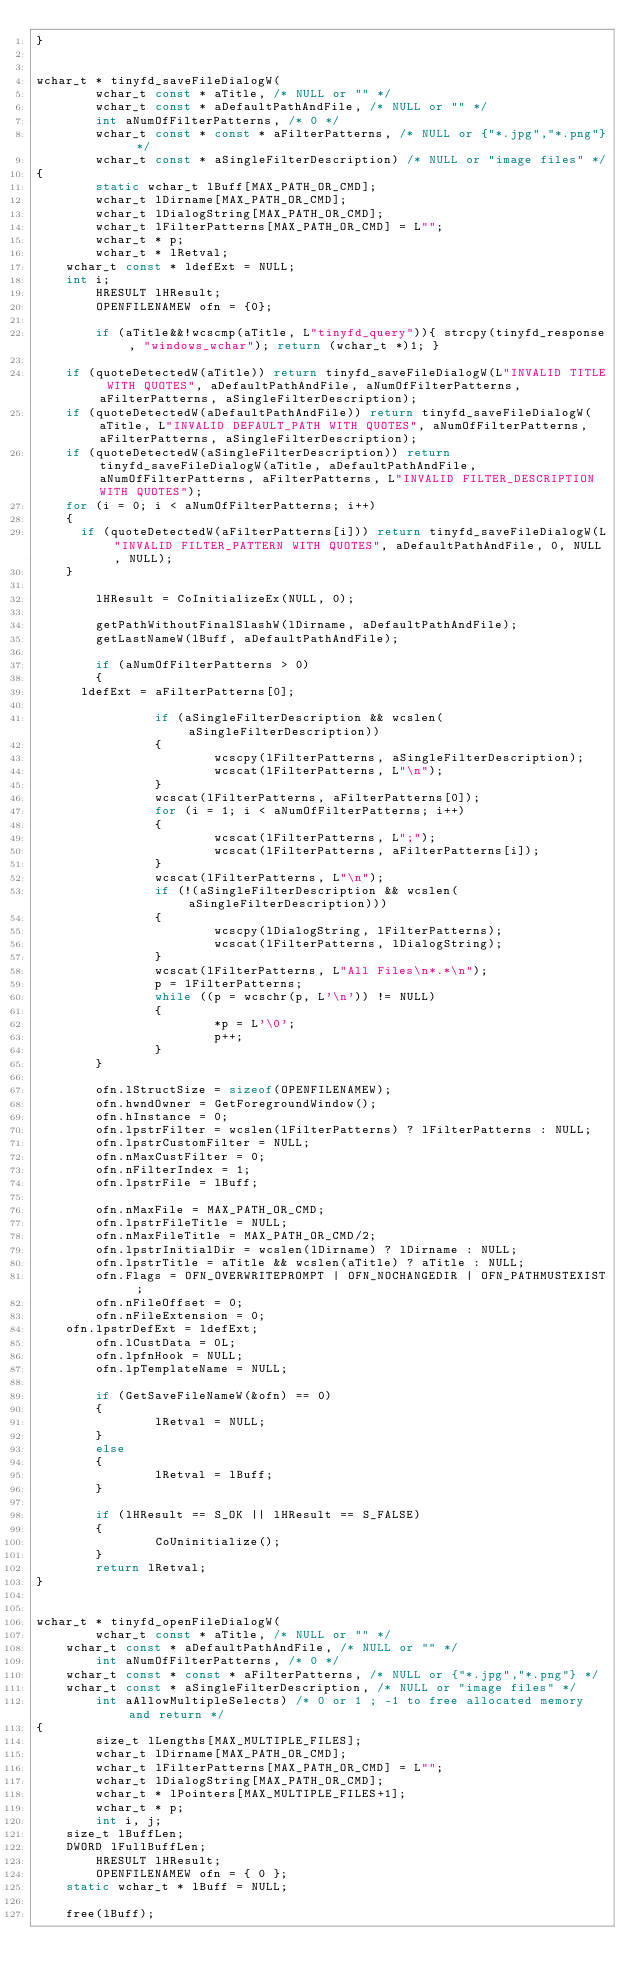<code> <loc_0><loc_0><loc_500><loc_500><_C_>}


wchar_t * tinyfd_saveFileDialogW(
        wchar_t const * aTitle, /* NULL or "" */
        wchar_t const * aDefaultPathAndFile, /* NULL or "" */
        int aNumOfFilterPatterns, /* 0 */
        wchar_t const * const * aFilterPatterns, /* NULL or {"*.jpg","*.png"} */
        wchar_t const * aSingleFilterDescription) /* NULL or "image files" */
{
        static wchar_t lBuff[MAX_PATH_OR_CMD];
        wchar_t lDirname[MAX_PATH_OR_CMD];
        wchar_t lDialogString[MAX_PATH_OR_CMD];
        wchar_t lFilterPatterns[MAX_PATH_OR_CMD] = L"";
        wchar_t * p;
        wchar_t * lRetval;
		wchar_t const * ldefExt = NULL;
		int i;
        HRESULT lHResult;
        OPENFILENAMEW ofn = {0};

        if (aTitle&&!wcscmp(aTitle, L"tinyfd_query")){ strcpy(tinyfd_response, "windows_wchar"); return (wchar_t *)1; }

		if (quoteDetectedW(aTitle)) return tinyfd_saveFileDialogW(L"INVALID TITLE WITH QUOTES", aDefaultPathAndFile, aNumOfFilterPatterns, aFilterPatterns, aSingleFilterDescription);
		if (quoteDetectedW(aDefaultPathAndFile)) return tinyfd_saveFileDialogW(aTitle, L"INVALID DEFAULT_PATH WITH QUOTES", aNumOfFilterPatterns, aFilterPatterns, aSingleFilterDescription);
		if (quoteDetectedW(aSingleFilterDescription)) return tinyfd_saveFileDialogW(aTitle, aDefaultPathAndFile, aNumOfFilterPatterns, aFilterPatterns, L"INVALID FILTER_DESCRIPTION WITH QUOTES");
		for (i = 0; i < aNumOfFilterPatterns; i++)
		{
			if (quoteDetectedW(aFilterPatterns[i])) return tinyfd_saveFileDialogW(L"INVALID FILTER_PATTERN WITH QUOTES", aDefaultPathAndFile, 0, NULL, NULL);
		}

        lHResult = CoInitializeEx(NULL, 0);

        getPathWithoutFinalSlashW(lDirname, aDefaultPathAndFile);
        getLastNameW(lBuff, aDefaultPathAndFile);

        if (aNumOfFilterPatterns > 0)
        {
			ldefExt = aFilterPatterns[0];

                if (aSingleFilterDescription && wcslen(aSingleFilterDescription))
                {
                        wcscpy(lFilterPatterns, aSingleFilterDescription);
                        wcscat(lFilterPatterns, L"\n");
                }
                wcscat(lFilterPatterns, aFilterPatterns[0]);
                for (i = 1; i < aNumOfFilterPatterns; i++)
                {
                        wcscat(lFilterPatterns, L";");
                        wcscat(lFilterPatterns, aFilterPatterns[i]);
                }
                wcscat(lFilterPatterns, L"\n");
                if (!(aSingleFilterDescription && wcslen(aSingleFilterDescription)))
                {
                        wcscpy(lDialogString, lFilterPatterns);
                        wcscat(lFilterPatterns, lDialogString);
                }
                wcscat(lFilterPatterns, L"All Files\n*.*\n");
                p = lFilterPatterns;
                while ((p = wcschr(p, L'\n')) != NULL)
                {
                        *p = L'\0';
                        p++;
                }
        }

        ofn.lStructSize = sizeof(OPENFILENAMEW);
        ofn.hwndOwner = GetForegroundWindow();
        ofn.hInstance = 0;
        ofn.lpstrFilter = wcslen(lFilterPatterns) ? lFilterPatterns : NULL;
        ofn.lpstrCustomFilter = NULL;
        ofn.nMaxCustFilter = 0;
        ofn.nFilterIndex = 1;
        ofn.lpstrFile = lBuff;

        ofn.nMaxFile = MAX_PATH_OR_CMD;
        ofn.lpstrFileTitle = NULL;
        ofn.nMaxFileTitle = MAX_PATH_OR_CMD/2;
        ofn.lpstrInitialDir = wcslen(lDirname) ? lDirname : NULL;
        ofn.lpstrTitle = aTitle && wcslen(aTitle) ? aTitle : NULL;
        ofn.Flags = OFN_OVERWRITEPROMPT | OFN_NOCHANGEDIR | OFN_PATHMUSTEXIST ;
        ofn.nFileOffset = 0;
        ofn.nFileExtension = 0;
		ofn.lpstrDefExt = ldefExt;
        ofn.lCustData = 0L;
        ofn.lpfnHook = NULL;
        ofn.lpTemplateName = NULL;

        if (GetSaveFileNameW(&ofn) == 0)
        {
                lRetval = NULL;
        }
        else
        {
                lRetval = lBuff;
        }

        if (lHResult == S_OK || lHResult == S_FALSE)
        {
                CoUninitialize();
        }
        return lRetval;
}


wchar_t * tinyfd_openFileDialogW(
        wchar_t const * aTitle, /* NULL or "" */
		wchar_t const * aDefaultPathAndFile, /* NULL or "" */
        int aNumOfFilterPatterns, /* 0 */
		wchar_t const * const * aFilterPatterns, /* NULL or {"*.jpg","*.png"} */
		wchar_t const * aSingleFilterDescription, /* NULL or "image files" */
        int aAllowMultipleSelects) /* 0 or 1 ; -1 to free allocated memory and return */
{
        size_t lLengths[MAX_MULTIPLE_FILES];
        wchar_t lDirname[MAX_PATH_OR_CMD];
        wchar_t lFilterPatterns[MAX_PATH_OR_CMD] = L"";
        wchar_t lDialogString[MAX_PATH_OR_CMD];
        wchar_t * lPointers[MAX_MULTIPLE_FILES+1];
        wchar_t * p;
        int i, j;
		size_t lBuffLen;
		DWORD lFullBuffLen;
        HRESULT lHResult;
        OPENFILENAMEW ofn = { 0 };
		static wchar_t * lBuff = NULL;

		free(lBuff);</code> 